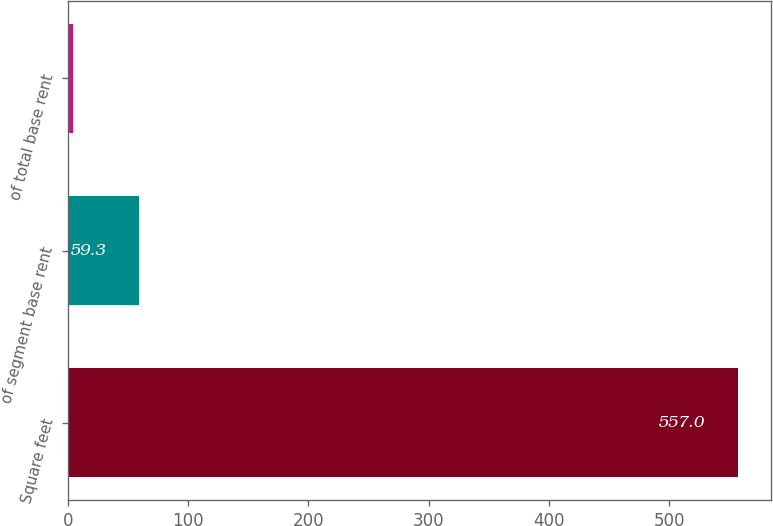Convert chart. <chart><loc_0><loc_0><loc_500><loc_500><bar_chart><fcel>Square feet<fcel>of segment base rent<fcel>of total base rent<nl><fcel>557<fcel>59.3<fcel>4<nl></chart> 